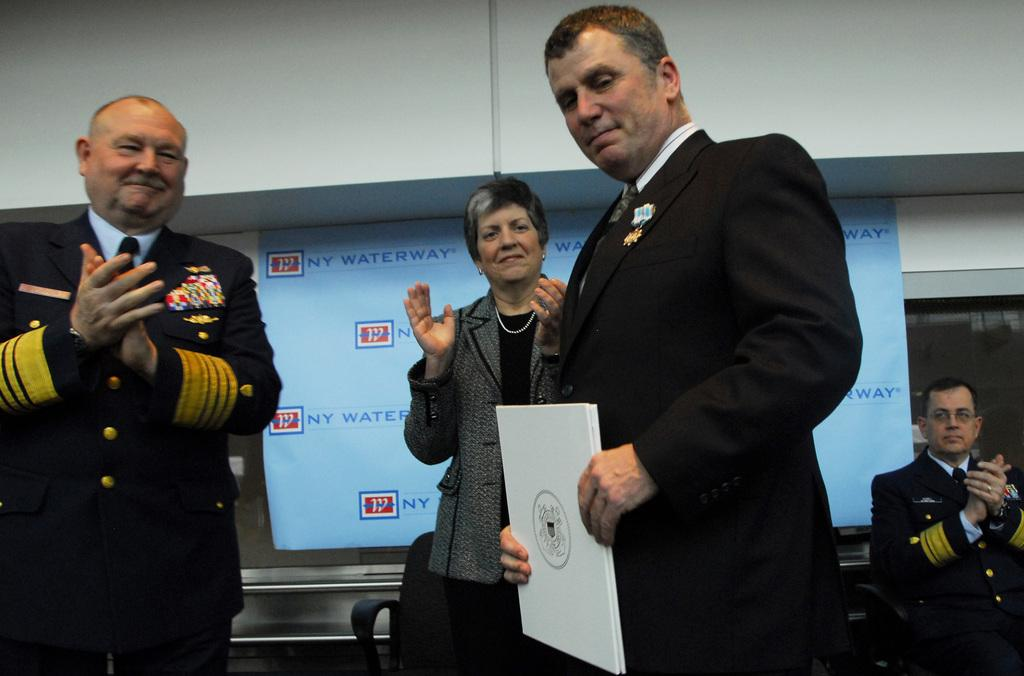How many people are in the image? There are persons standing in the image. What is one person holding in the image? One person is holding a book. What is attached to a window in the image? There is a banner attached to a window in the image. What type of structure is visible in the image? There is a wall visible in the image. What type of laborer can be seen working on the wall in the image? There is no laborer or work on the wall visible in the image. How many sheep are present in the image? There are no sheep present in the image. 